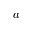<formula> <loc_0><loc_0><loc_500><loc_500>a</formula> 